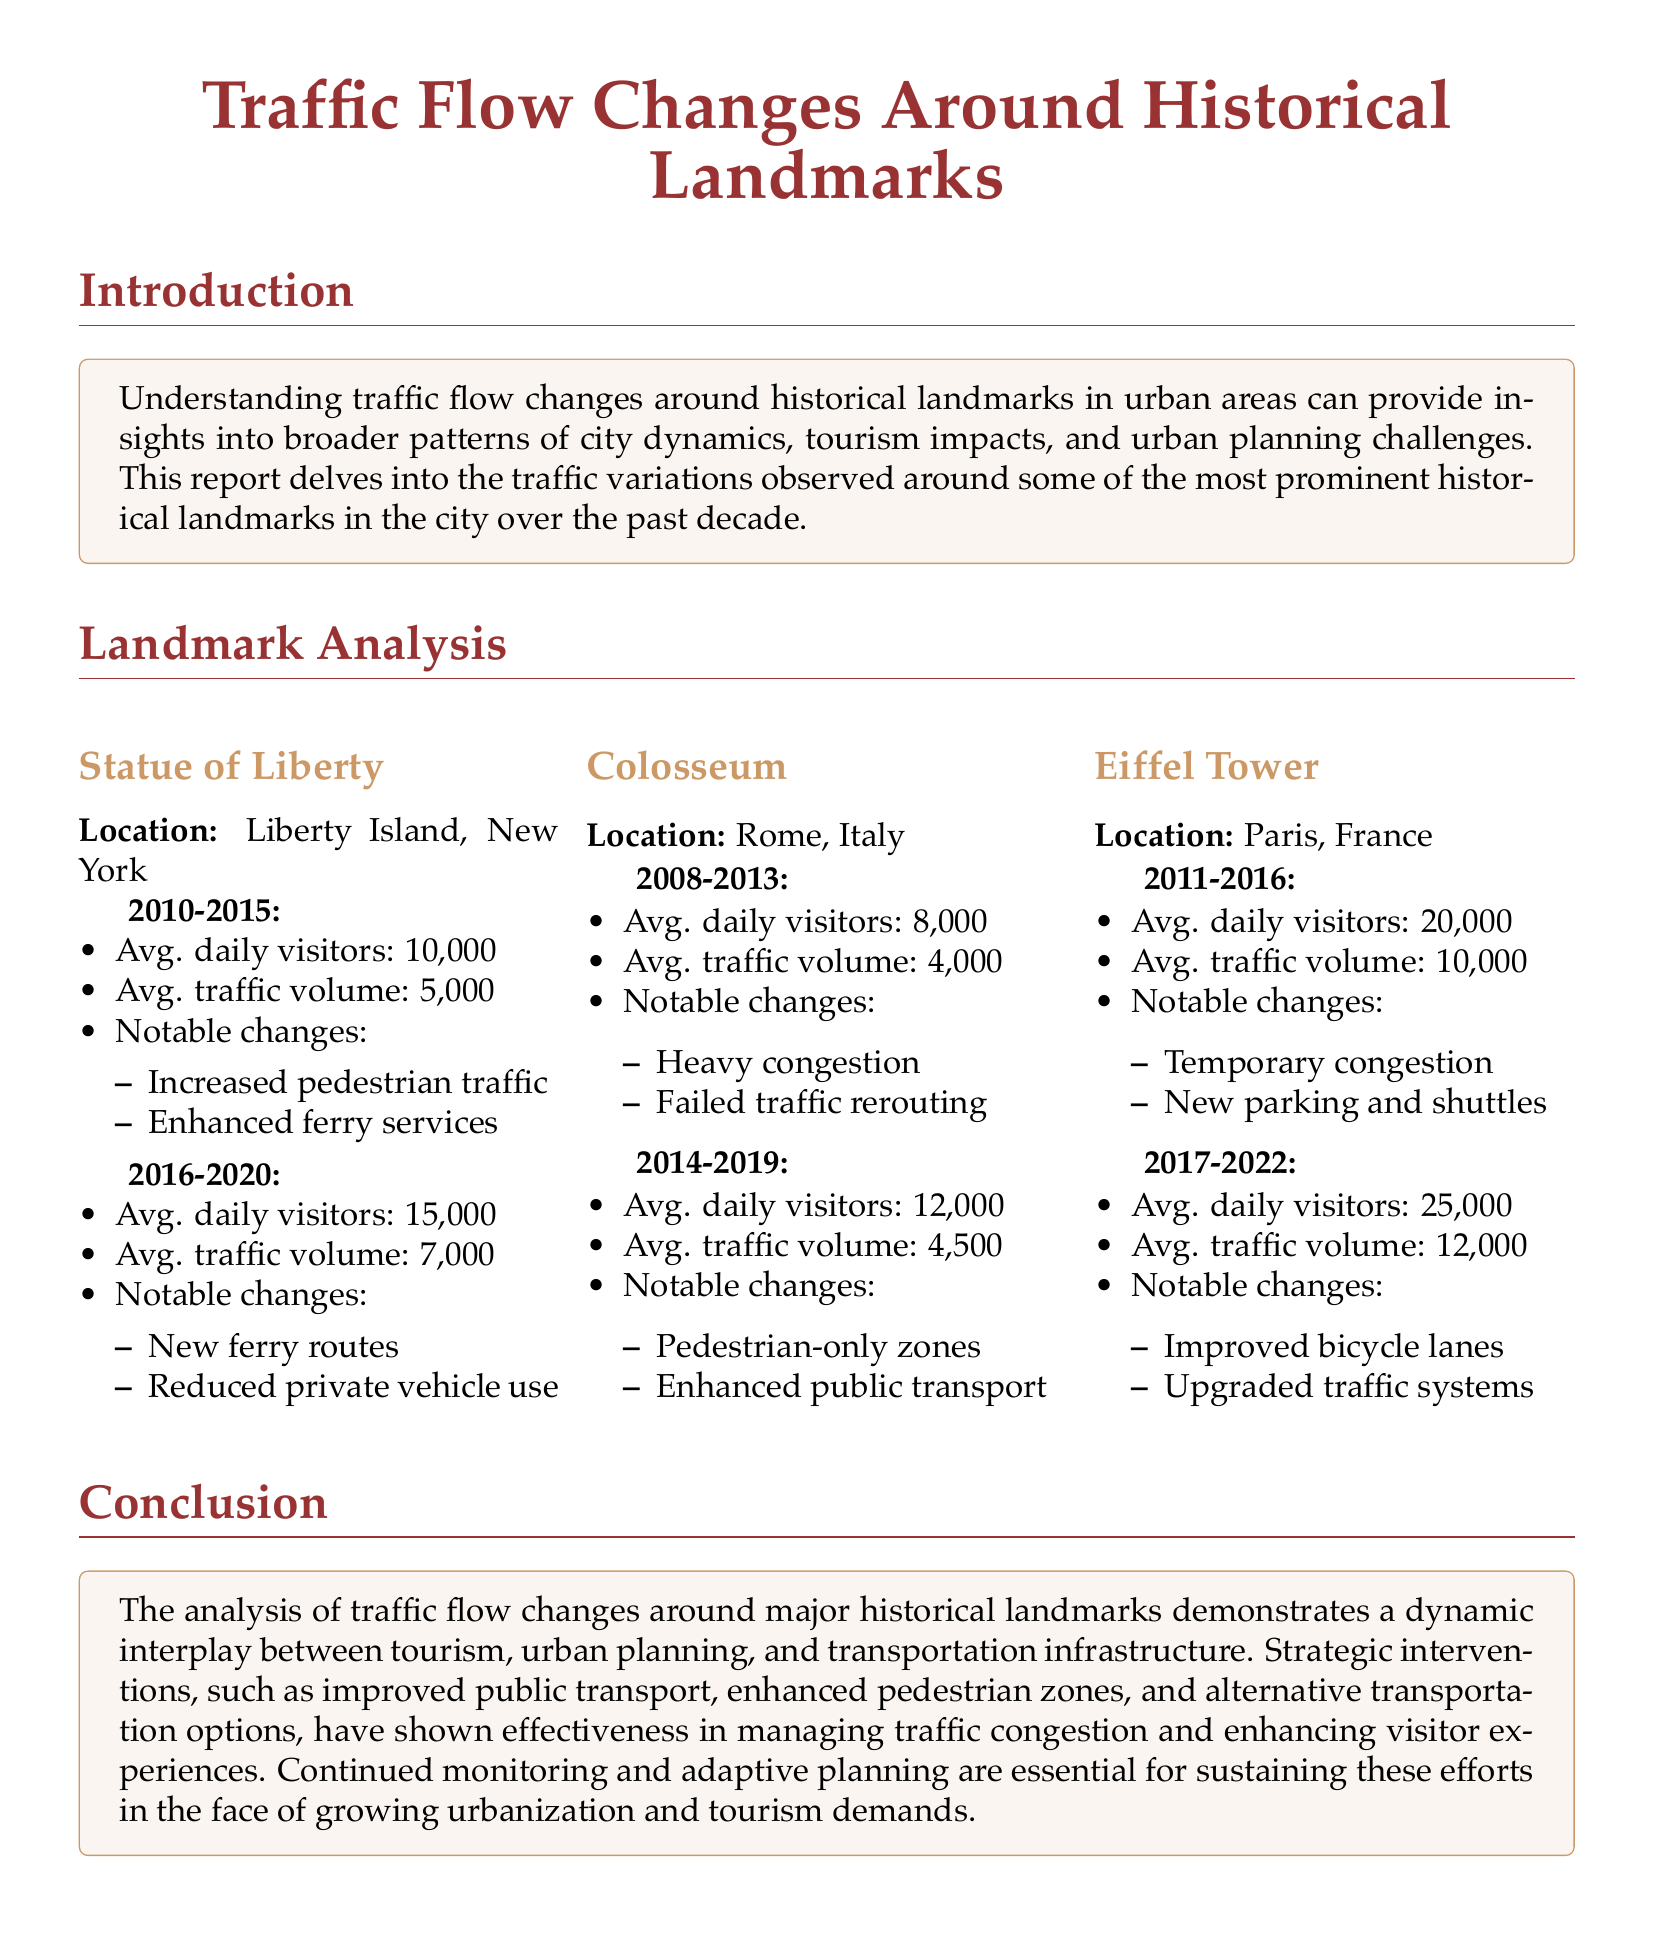What was the average daily visitors at the Statue of Liberty from 2016-2020? The average daily visitors during this period was 15,000.
Answer: 15,000 What notable traffic change occurred around the Eiffel Tower from 2011-2016? The notable change mentioned is "Temporary congestion."
Answer: Temporary congestion What was the average traffic volume around the Colosseum in the period 2014-2019? The average traffic volume reported was 4,500.
Answer: 4,500 What year range indicates the increase of daily visitors at the Statue of Liberty? The report indicates an increase in visitors from 2010-2015 to 2016-2020.
Answer: 2010-2015 to 2016-2020 Which historical landmark had the highest average daily visitors in the report? The Eiffel Tower had the highest average daily visitors at 25,000.
Answer: Eiffel Tower What type of transportation improvement was noted for the Statue of Liberty between 2016-2020? The report mentions "New ferry routes" as a transportation improvement.
Answer: New ferry routes What was a notable change related to traffic around the Colosseum between 2008-2013? The notable change was "Heavy congestion."
Answer: Heavy congestion What does the conclusion of the report emphasize for future planning? The conclusion emphasizes the need for "Continued monitoring and adaptive planning."
Answer: Continued monitoring and adaptive planning 